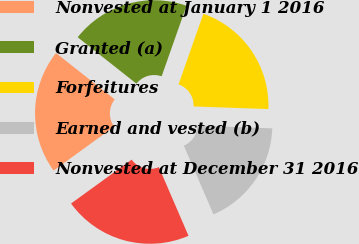Convert chart to OTSL. <chart><loc_0><loc_0><loc_500><loc_500><pie_chart><fcel>Nonvested at January 1 2016<fcel>Granted (a)<fcel>Forfeitures<fcel>Earned and vested (b)<fcel>Nonvested at December 31 2016<nl><fcel>20.62%<fcel>19.75%<fcel>20.17%<fcel>17.96%<fcel>21.5%<nl></chart> 